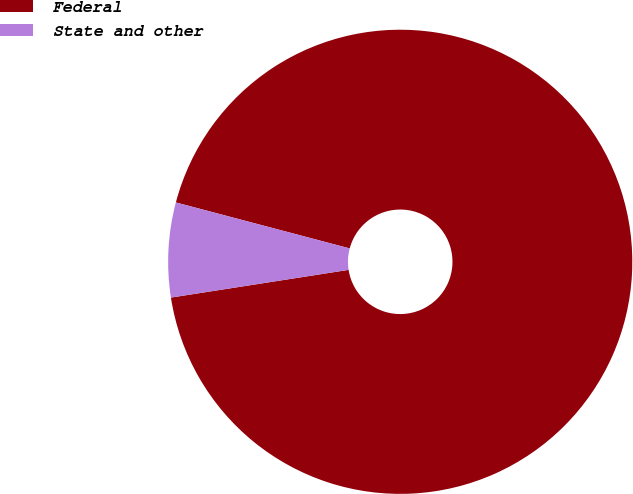Convert chart to OTSL. <chart><loc_0><loc_0><loc_500><loc_500><pie_chart><fcel>Federal<fcel>State and other<nl><fcel>93.42%<fcel>6.58%<nl></chart> 